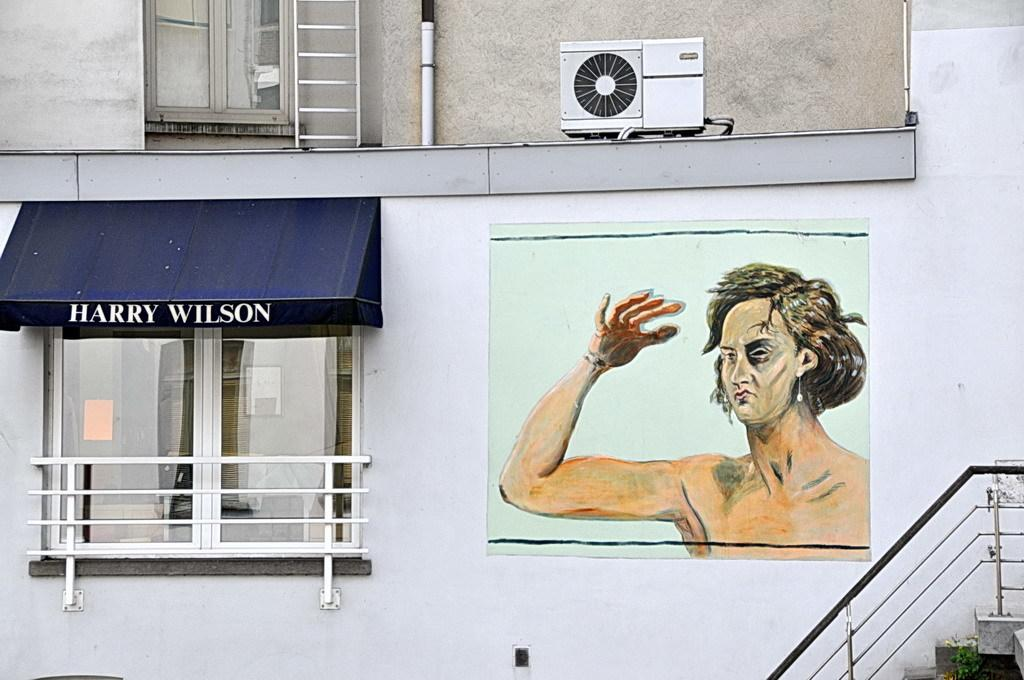<image>
Render a clear and concise summary of the photo. A shopfront labeled "Harry Wilson" sits next to a nicely done mural. 